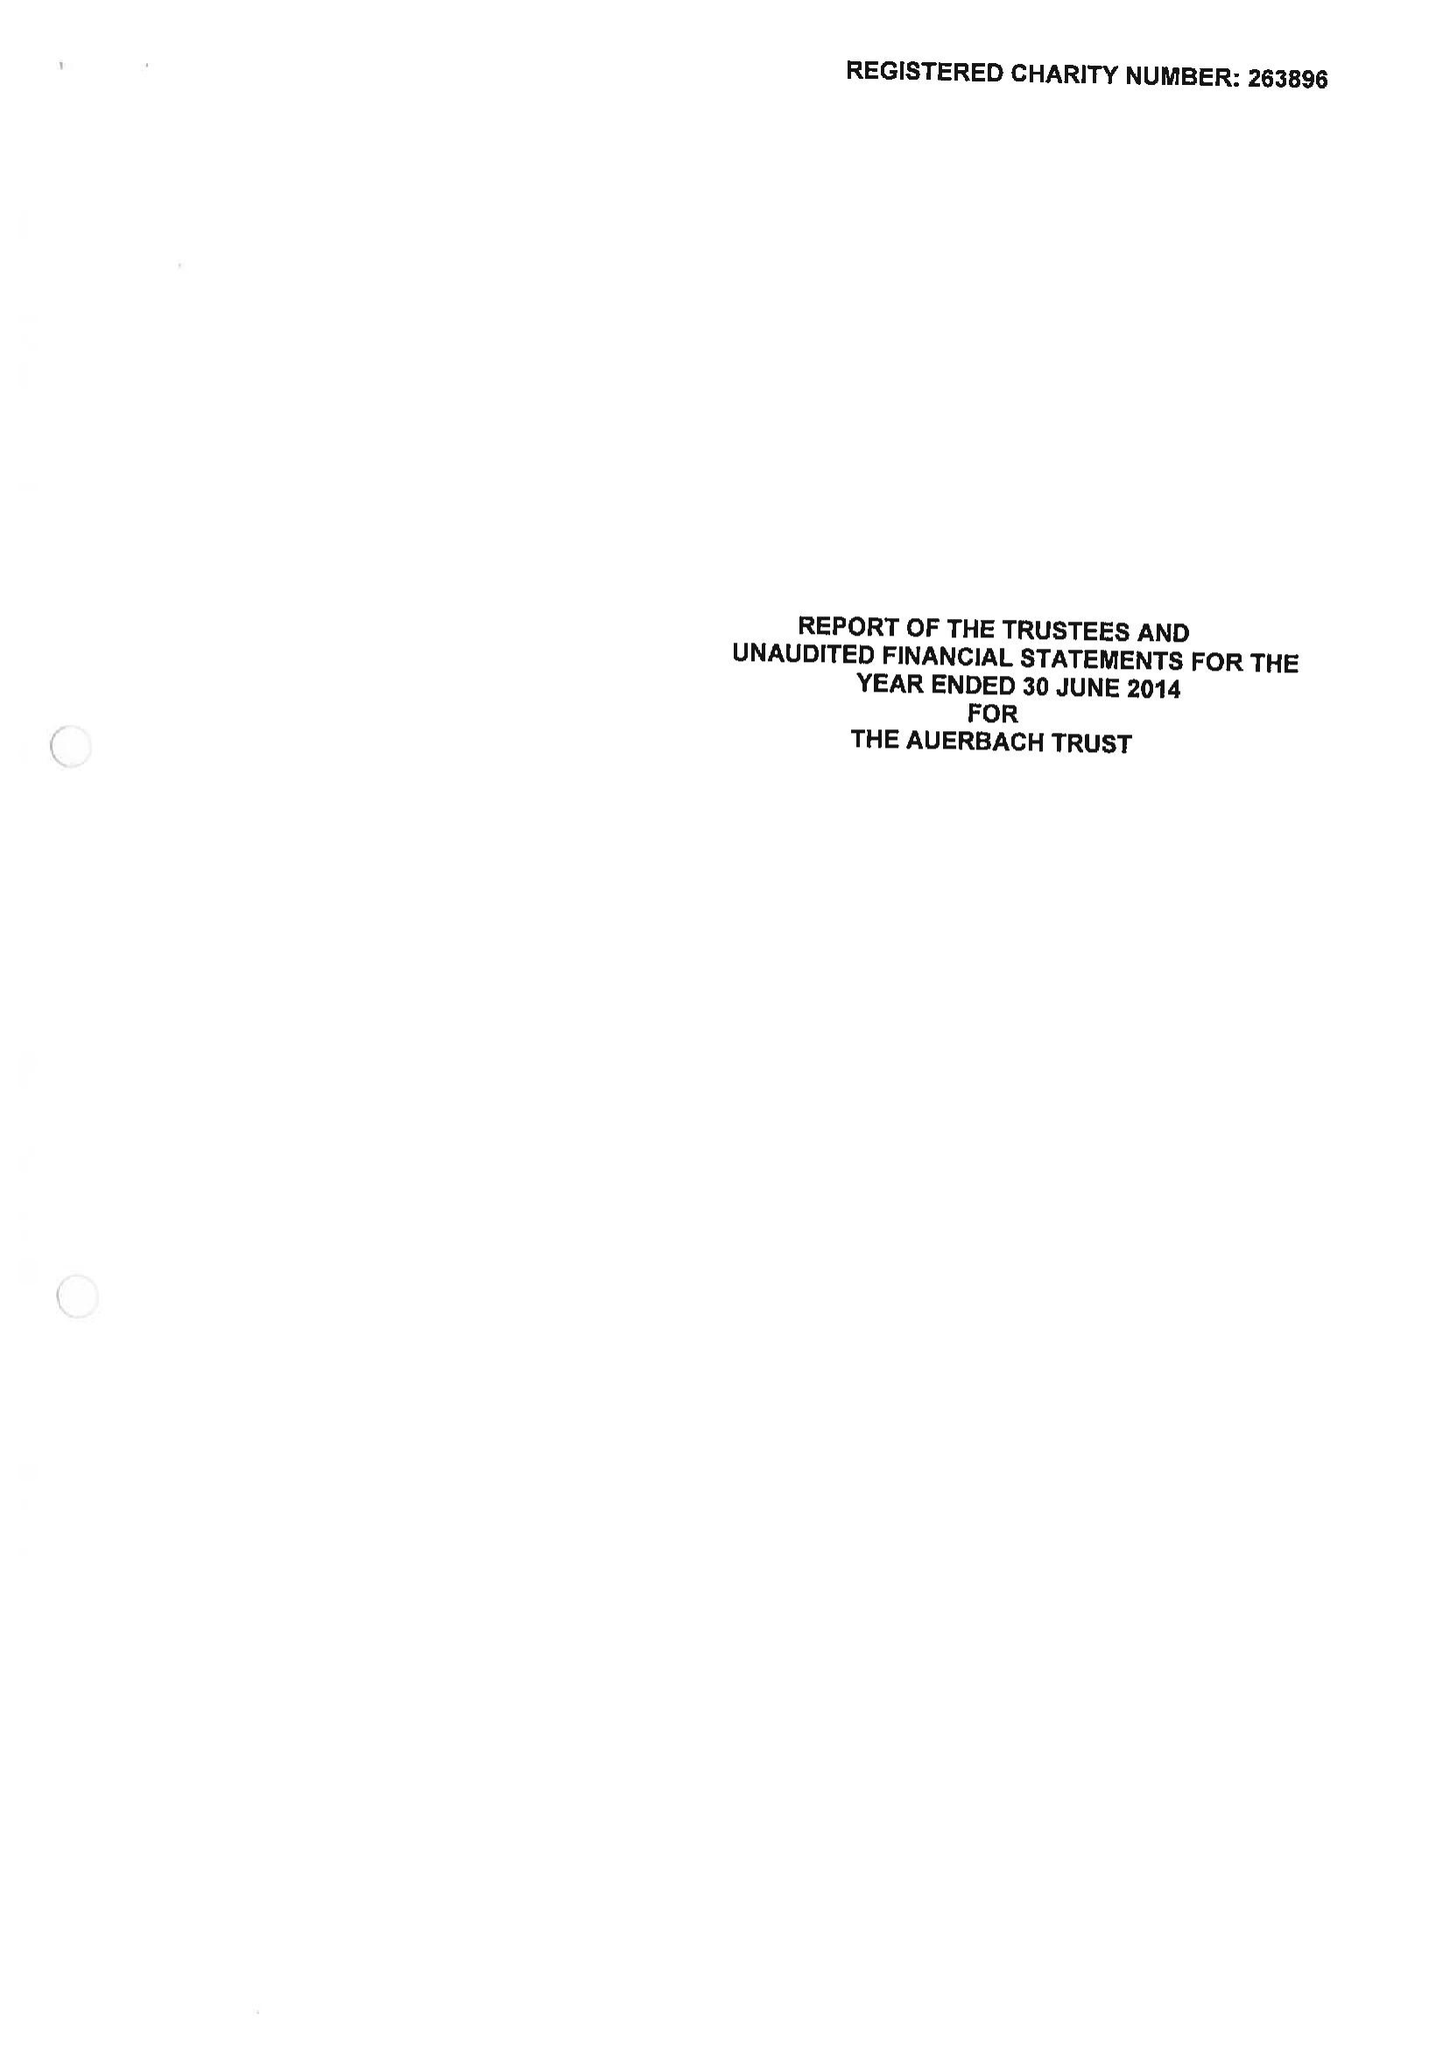What is the value for the address__street_line?
Answer the question using a single word or phrase. 21 CLARENCE TERRACE 